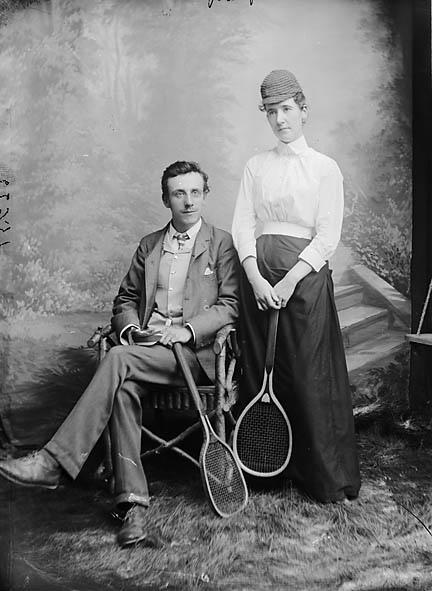Does this picture looked staged?
Answer briefly. Yes. Why are the people holding rackets if they are not playing a game?
Be succinct. Posing for picture. What sport is this?
Give a very brief answer. Tennis. Is this a recent photograph?
Answer briefly. No. Is one of the people wearing a blue coat?
Write a very short answer. No. 